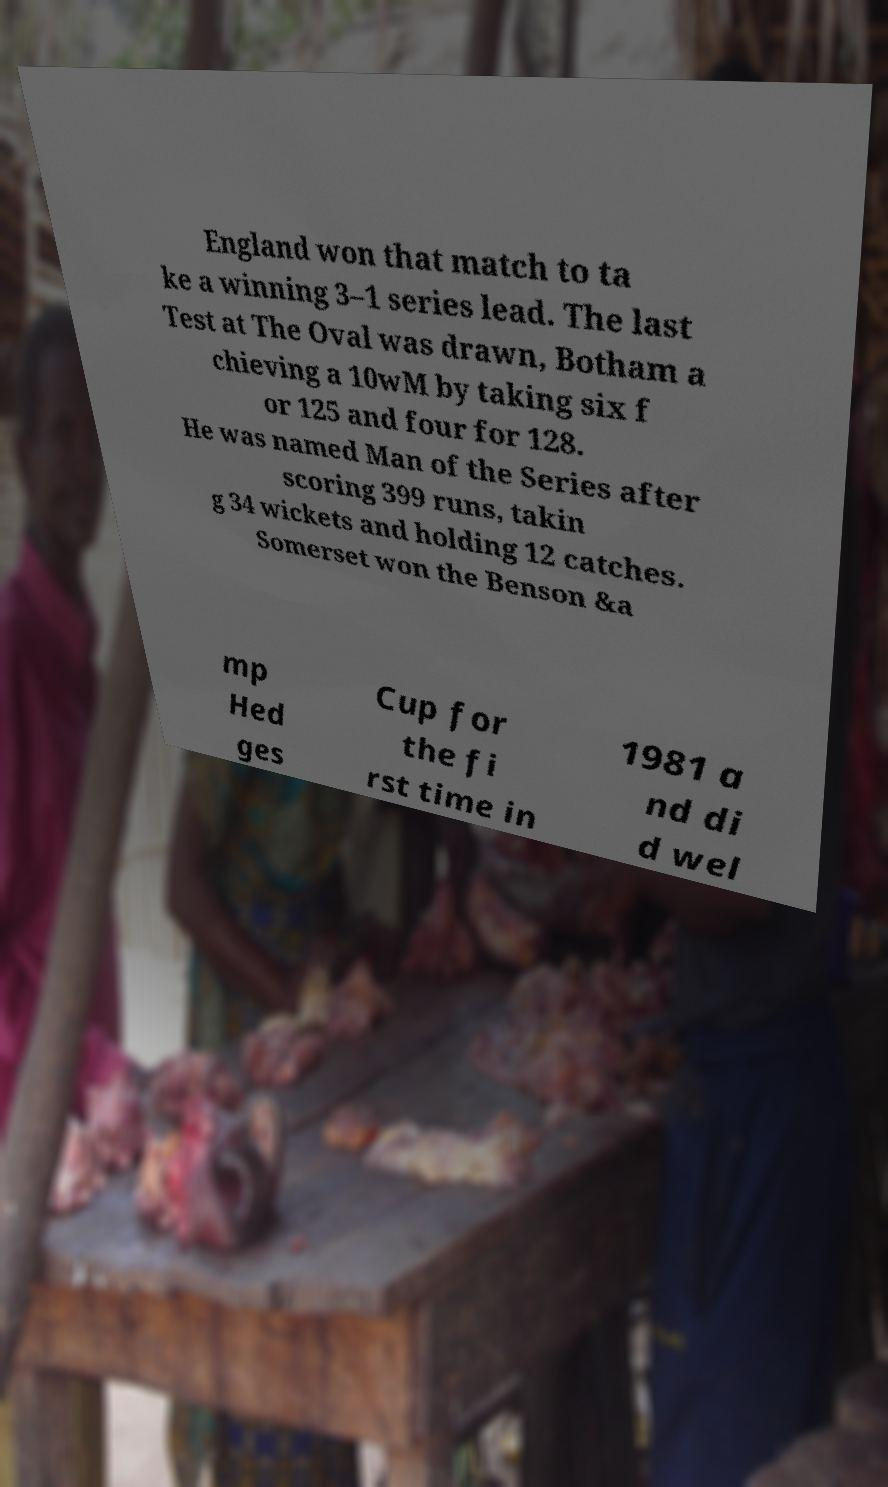Could you extract and type out the text from this image? England won that match to ta ke a winning 3–1 series lead. The last Test at The Oval was drawn, Botham a chieving a 10wM by taking six f or 125 and four for 128. He was named Man of the Series after scoring 399 runs, takin g 34 wickets and holding 12 catches. Somerset won the Benson &a mp Hed ges Cup for the fi rst time in 1981 a nd di d wel 